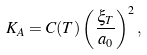<formula> <loc_0><loc_0><loc_500><loc_500>K _ { A } = C ( T ) \left ( \frac { \xi _ { T } } { a _ { 0 } } \right ) ^ { 2 } ,</formula> 